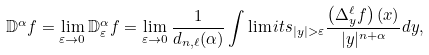<formula> <loc_0><loc_0><loc_500><loc_500>\mathbb { D } ^ { \alpha } f = \lim _ { \varepsilon \to 0 } \mathbb { D } ^ { \alpha } _ { \varepsilon } f = \lim _ { \varepsilon \to 0 } \frac { 1 } { d _ { n , \ell } ( \alpha ) } \int \lim i t s _ { | y | > \varepsilon } \frac { \left ( \Delta ^ { \ell } _ { y } f \right ) ( x ) } { | y | ^ { n + \alpha } } d y ,</formula> 